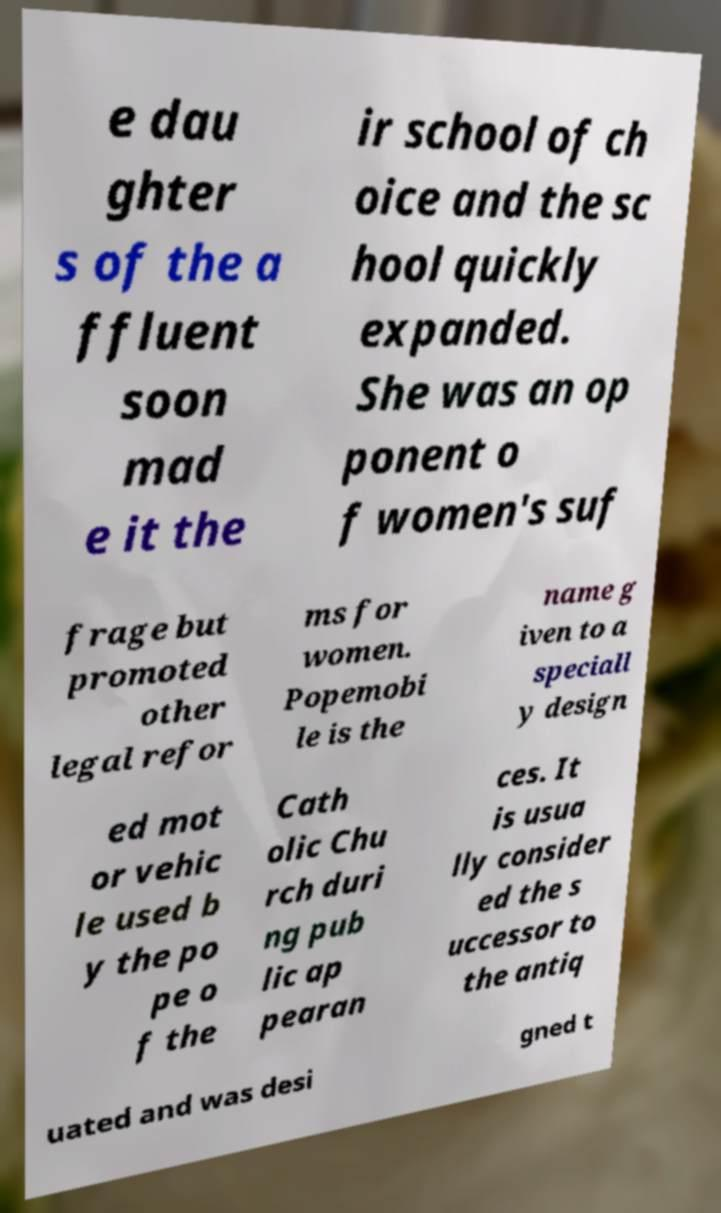I need the written content from this picture converted into text. Can you do that? e dau ghter s of the a ffluent soon mad e it the ir school of ch oice and the sc hool quickly expanded. She was an op ponent o f women's suf frage but promoted other legal refor ms for women. Popemobi le is the name g iven to a speciall y design ed mot or vehic le used b y the po pe o f the Cath olic Chu rch duri ng pub lic ap pearan ces. It is usua lly consider ed the s uccessor to the antiq uated and was desi gned t 